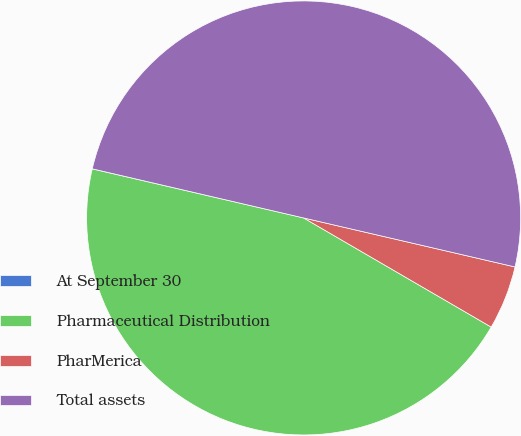Convert chart to OTSL. <chart><loc_0><loc_0><loc_500><loc_500><pie_chart><fcel>At September 30<fcel>Pharmaceutical Distribution<fcel>PharMerica<fcel>Total assets<nl><fcel>0.01%<fcel>45.24%<fcel>4.76%<fcel>49.99%<nl></chart> 